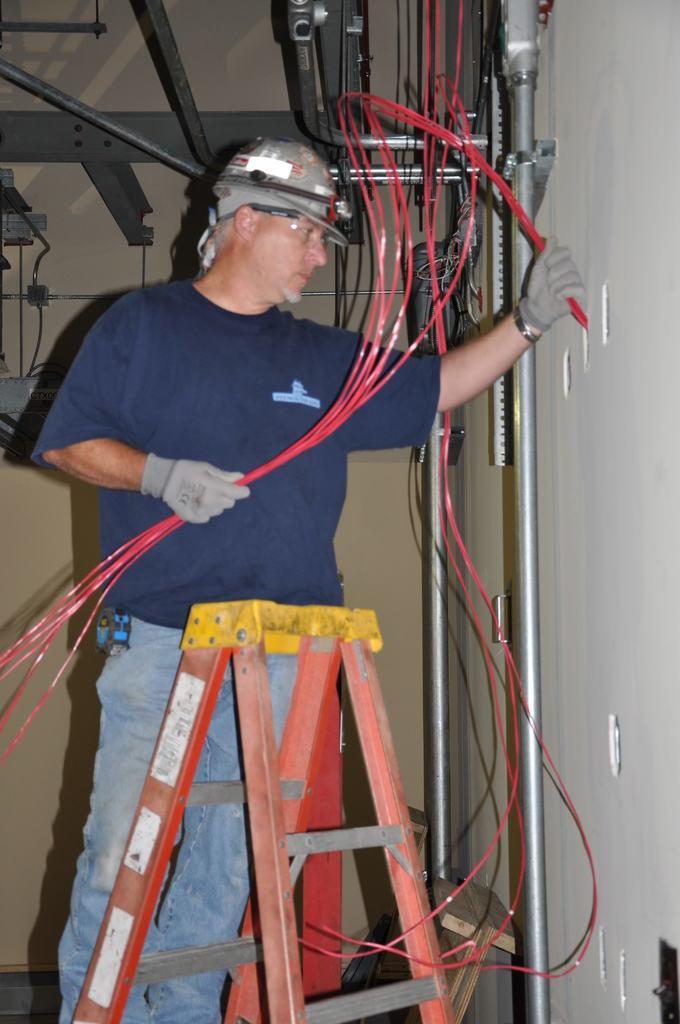Could you give a brief overview of what you see in this image? In this picture there is a man standing and holding cables and wire gloves and helmet, in front of him we can see stand. We can see rods, cables and table. In the background of the image we can see wall. 